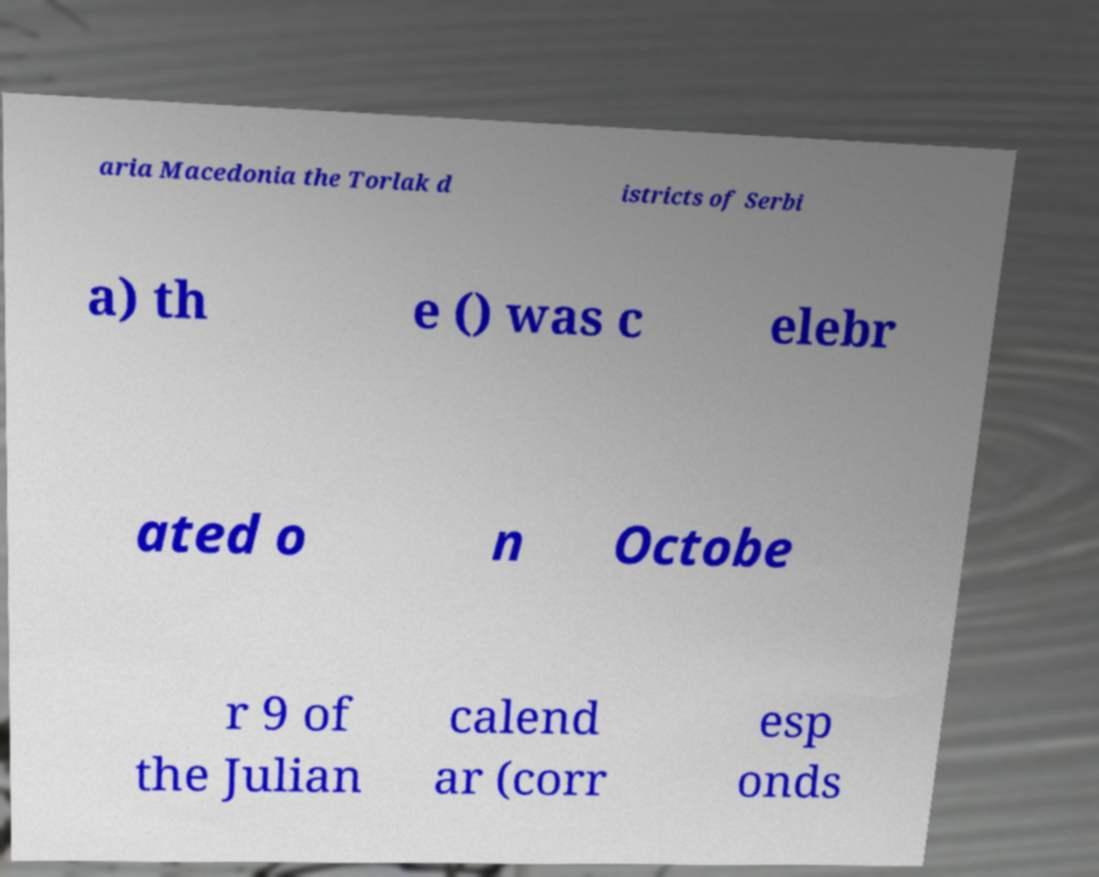What messages or text are displayed in this image? I need them in a readable, typed format. aria Macedonia the Torlak d istricts of Serbi a) th e () was c elebr ated o n Octobe r 9 of the Julian calend ar (corr esp onds 